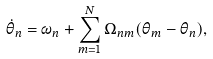<formula> <loc_0><loc_0><loc_500><loc_500>\dot { \theta } _ { n } = \omega _ { n } + \sum _ { m = 1 } ^ { N } \Omega _ { n m } ( \theta _ { m } - \theta _ { n } ) ,</formula> 